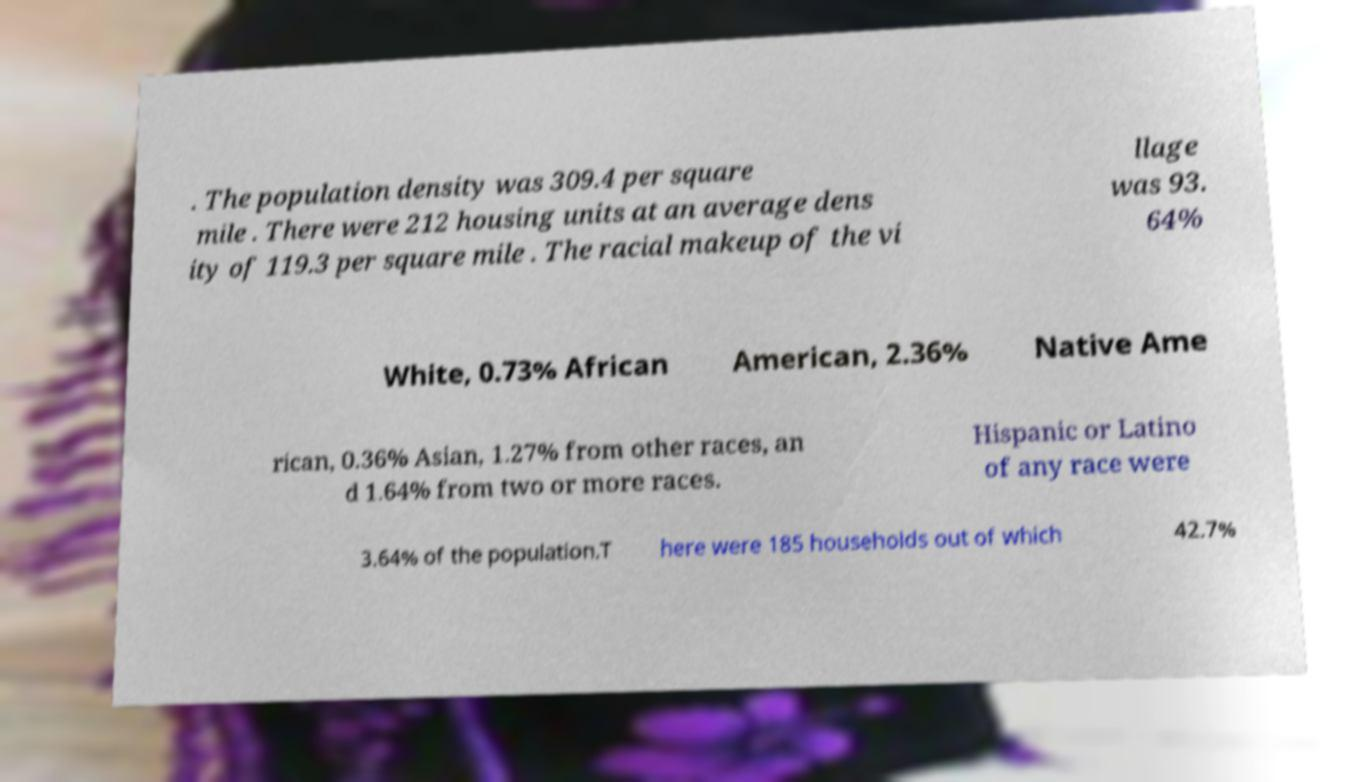Please read and relay the text visible in this image. What does it say? . The population density was 309.4 per square mile . There were 212 housing units at an average dens ity of 119.3 per square mile . The racial makeup of the vi llage was 93. 64% White, 0.73% African American, 2.36% Native Ame rican, 0.36% Asian, 1.27% from other races, an d 1.64% from two or more races. Hispanic or Latino of any race were 3.64% of the population.T here were 185 households out of which 42.7% 